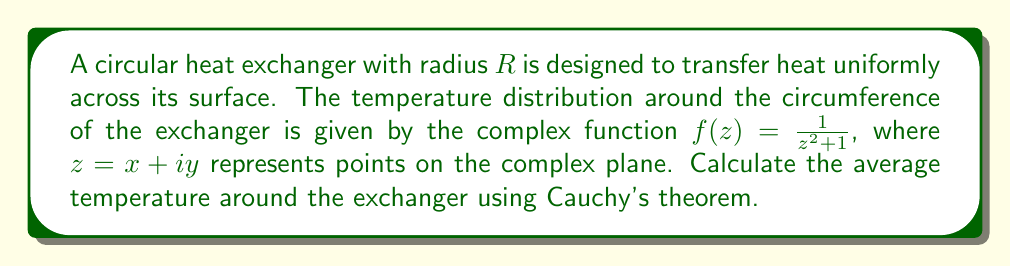Help me with this question. To solve this problem, we'll follow these steps:

1) The average temperature around the circular heat exchanger can be found by evaluating the contour integral:

   $$\frac{1}{2\pi i} \oint_C f(z) dz$$

   where $C$ is the circular contour with radius $R$ centered at the origin.

2) According to Cauchy's theorem, if $f(z)$ is analytic inside and on a simple closed contour $C$, then:

   $$\oint_C f(z) dz = 0$$

3) In our case, $f(z) = \frac{1}{z^2 + 1}$ has poles at $z = \pm i$. For $R > 1$, our contour encloses both these poles.

4) We can use the residue theorem, which states:

   $$\oint_C f(z) dz = 2\pi i \sum \text{Res}(f, a_k)$$

   where $a_k$ are the poles of $f(z)$ inside $C$.

5) To find the residues:

   At $z = i$: $\text{Res}(f, i) = \lim_{z \to i} (z-i)f(z) = \lim_{z \to i} \frac{z-i}{z^2+1} = \frac{1}{2i}$

   At $z = -i$: $\text{Res}(f, -i) = \lim_{z \to -i} (z+i)f(z) = \lim_{z \to -i} \frac{z+i}{z^2+1} = -\frac{1}{2i}$

6) Summing the residues:

   $$\sum \text{Res}(f, a_k) = \frac{1}{2i} - \frac{1}{2i} = 0$$

7) Therefore, $\oint_C f(z) dz = 2\pi i (0) = 0$

8) The average temperature is thus:

   $$\frac{1}{2\pi i} \oint_C f(z) dz = \frac{1}{2\pi i} (0) = 0$$
Answer: The average temperature around the circular heat exchanger is 0. 